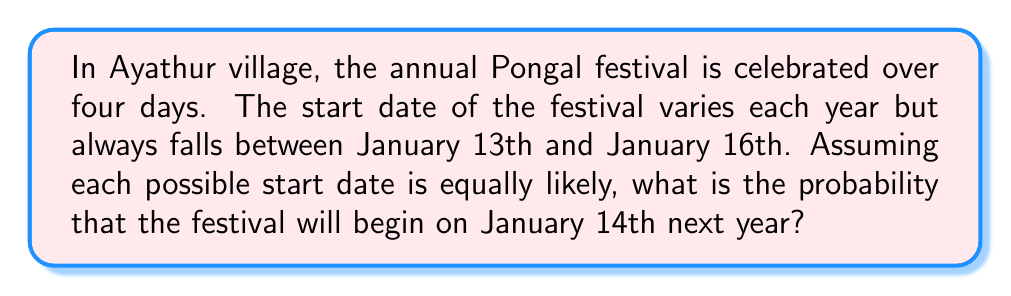Could you help me with this problem? To solve this problem, we'll use the principles of Bayesian probability. Let's break it down step-by-step:

1. Identify the sample space:
   The festival can start on any day from January 13th to January 16th.
   Sample space = {Jan 13, Jan 14, Jan 15, Jan 16}

2. Count the number of possible outcomes:
   There are 4 possible start dates.

3. Identify the favorable outcome:
   We're interested in the probability of the festival starting on January 14th.

4. Apply the classical probability formula:

   $$P(\text{Event}) = \frac{\text{Number of favorable outcomes}}{\text{Total number of possible outcomes}}$$

5. Calculate the probability:
   $$P(\text{Jan 14th}) = \frac{1}{4} = 0.25$$

This calculation assumes that each start date is equally likely, which is given in the problem statement. If we had additional information about the likelihood of specific dates, we would need to adjust our probability calculation accordingly.
Answer: The probability that the Pongal festival will begin on January 14th next year is $\frac{1}{4}$ or 0.25 or 25%. 